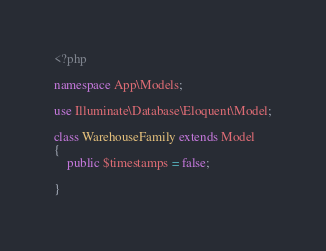<code> <loc_0><loc_0><loc_500><loc_500><_PHP_><?php

namespace App\Models;

use Illuminate\Database\Eloquent\Model;

class WarehouseFamily extends Model
{
    public $timestamps = false;
    
}
</code> 